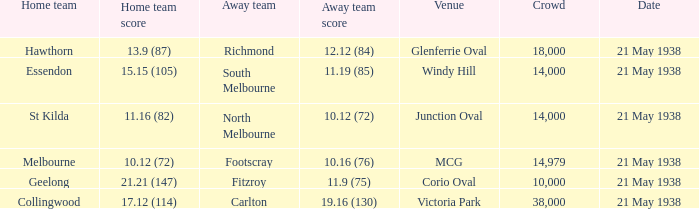Which visiting team has an audience greater than 14,000 and a home team from melbourne? Footscray. 